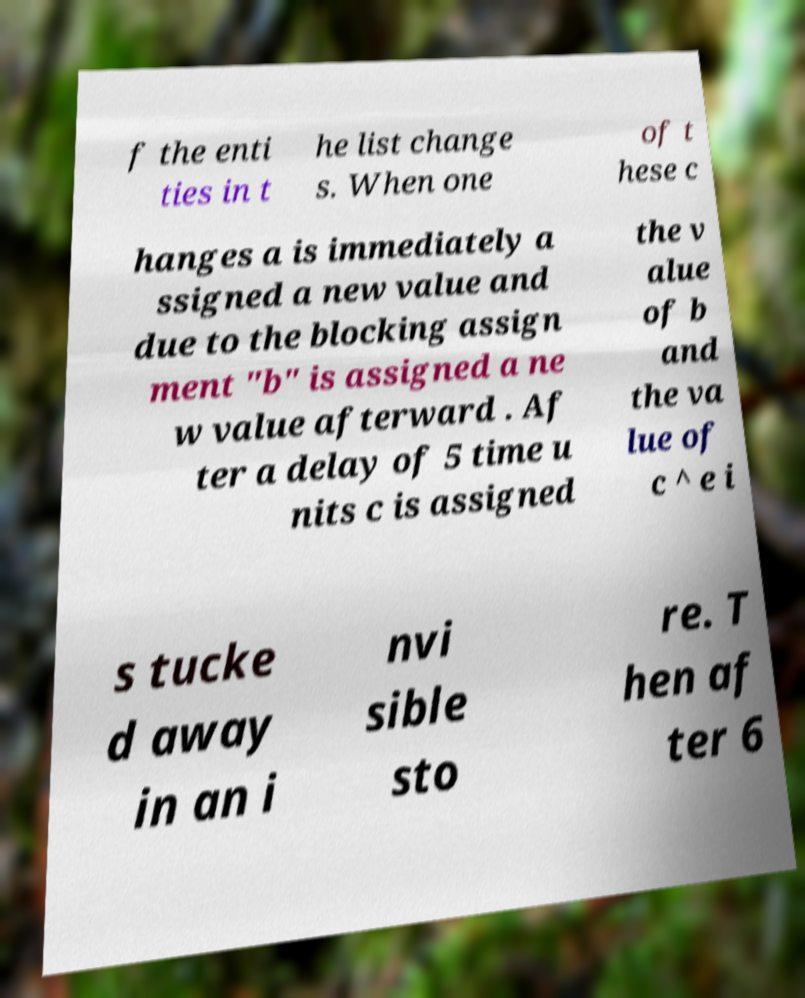Please read and relay the text visible in this image. What does it say? f the enti ties in t he list change s. When one of t hese c hanges a is immediately a ssigned a new value and due to the blocking assign ment "b" is assigned a ne w value afterward . Af ter a delay of 5 time u nits c is assigned the v alue of b and the va lue of c ^ e i s tucke d away in an i nvi sible sto re. T hen af ter 6 